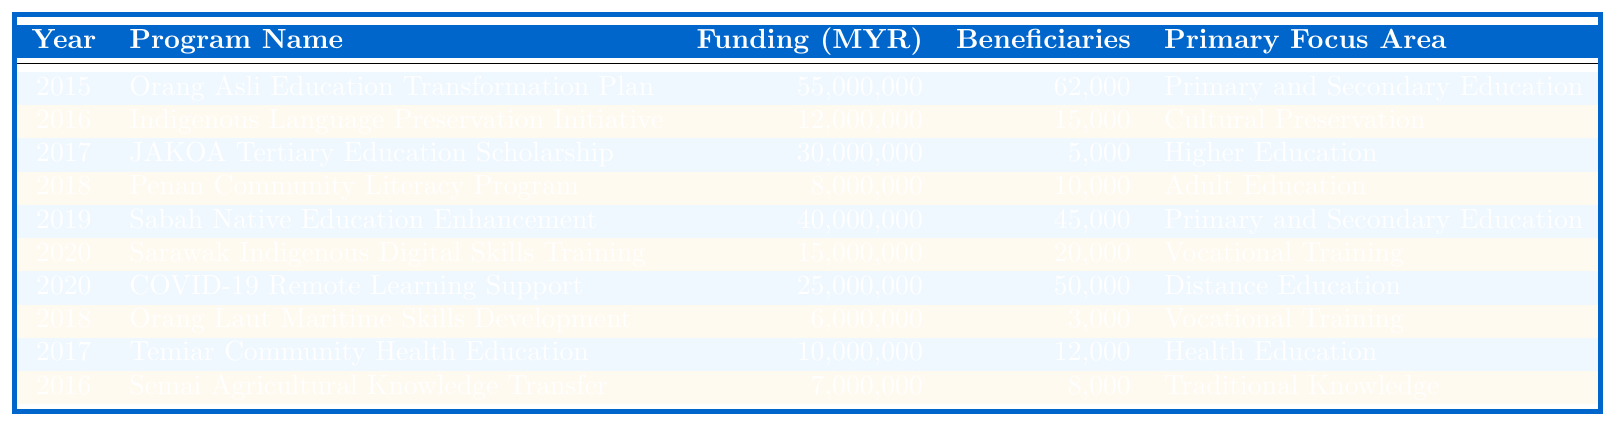What was the total funding allocated to indigenous education programs in 2015? The funding for 2015 is listed as 55,000,000 MYR for the "Orang Asli Education Transformation Plan". This is the only program for that year.
Answer: 55,000,000 MYR How many beneficiaries were there in total across all programs in 2018? In 2018, there were two programs: "Penan Community Literacy Program" with 10,000 beneficiaries and "Orang Laut Maritime Skills Development" with 3,000 beneficiaries. Adding these gives a total of 10,000 + 3,000 = 13,000 beneficiaries.
Answer: 13,000 Which program had the highest funding amount, and in which year was it allocated? The program with the highest funding is the "Orang Asli Education Transformation Plan" with 55,000,000 MYR in 2015.
Answer: Orang Asli Education Transformation Plan, 2015 Which year had the least total funding across all programs? Looking at the funding amounts for each year, 2018 has the least total funding with 8,000,000 MYR for the "Penan Community Literacy Program" and 6,000,000 MYR for "Orang Laut Maritime Skills Development", totaling 14,000,000 MYR.
Answer: 2018 Was there a program focused on cultural preservation? Yes, the "Indigenous Language Preservation Initiative" in 2016 focuses on cultural preservation.
Answer: Yes What was the average funding per beneficiary in 2019? In 2019, the "Sabah Native Education Enhancement" program had a funding amount of 40,000,000 MYR and 45,000 beneficiaries. The average funding per beneficiary is calculated by dividing the total funding by the number of beneficiaries: 40,000,000 / 45,000 = 888.89 MYR per beneficiary.
Answer: 888.89 MYR Calculate the total funding for vocational training programs across all years. The programs focusing on vocational training are "Sarawak Indigenous Digital Skills Training" with 15,000,000 MYR in 2020 and "Orang Laut Maritime Skills Development" with 6,000,000 MYR in 2018. The total funding is 15,000,000 + 6,000,000 = 21,000,000 MYR.
Answer: 21,000,000 MYR How does the number of beneficiaries in 2020 compare to that in 2017? In 2020, there were two programs with 50,000 beneficiaries ("COVID-19 Remote Learning Support for Indigenous Students") and 20,000 beneficiaries ("Sarawak Indigenous Digital Skills Training"), totaling 70,000. In 2017, there were 5,000 beneficiaries ("JAKOA Tertiary Education Scholarship"). Comparing these, 70,000 (2020) is much greater than 5,000 (2017).
Answer: 2020 had significantly more beneficiaries What was the total funding allocated to health education programs between 2015 and 2020? The only program focusing on health education is "Temiar Community Health Education" in 2017, which had a funding amount of 10,000,000 MYR. Therefore, the total funding allocated to health education programs is 10,000,000 MYR.
Answer: 10,000,000 MYR Was there any program supporting distance education? Yes, the program "COVID-19 Remote Learning Support for Indigenous Students" in 2020 supported distance education.
Answer: Yes 